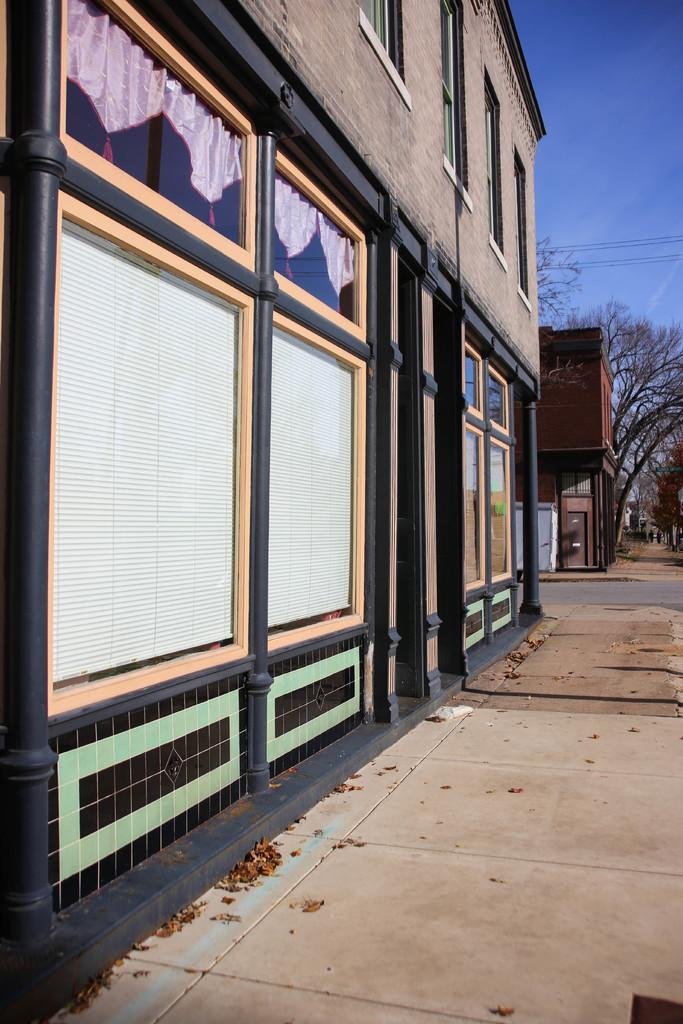What type of path can be seen in the image? There is a footpath in the image. What other type of path is present in the image? There is also a road in the image. What natural elements can be seen in the image? There are trees in the image. What man-made structures are visible in the image? There are buildings in the image. What type of window treatment is present in the image? There are curtains in the image. How many types of openings can be seen in the image? There are windows in the image. What other objects can be seen in the image? There are some objects in the image. What can be seen in the background of the image? The sky is visible in the background of the image. Can you see a carriage being pulled by horses in the image? There is no carriage being pulled by horses present in the image. Is there a recess in the wall where people can sit in the image? There is no recess in the wall where people can sit present in the image. 